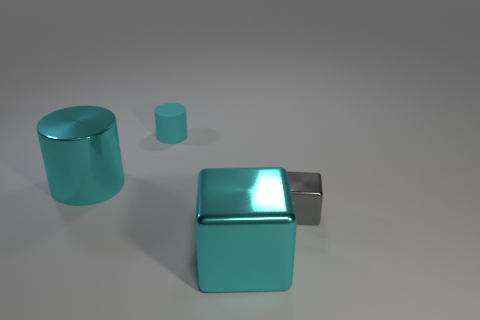Add 1 small cyan cylinders. How many objects exist? 5 Add 2 big things. How many big things are left? 4 Add 3 purple rubber objects. How many purple rubber objects exist? 3 Subtract 0 blue cylinders. How many objects are left? 4 Subtract all big cubes. Subtract all cyan metal objects. How many objects are left? 1 